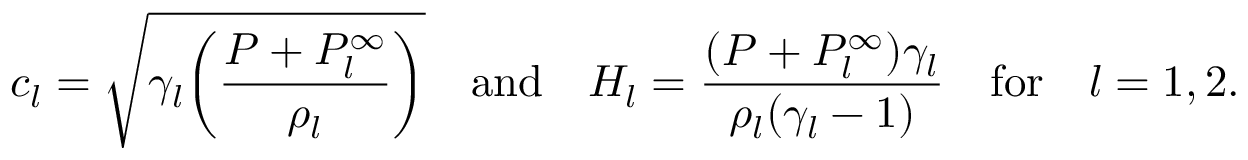Convert formula to latex. <formula><loc_0><loc_0><loc_500><loc_500>c _ { l } = \sqrt { \gamma _ { l } \left ( \frac { P + P _ { l } ^ { \infty } } { \rho _ { l } } \right ) } \quad a n d \quad H _ { l } = \frac { ( P + P _ { l } ^ { \infty } ) \gamma _ { l } } { \rho _ { l } ( \gamma _ { l } - 1 ) } \quad f o r \quad l = 1 , 2 .</formula> 